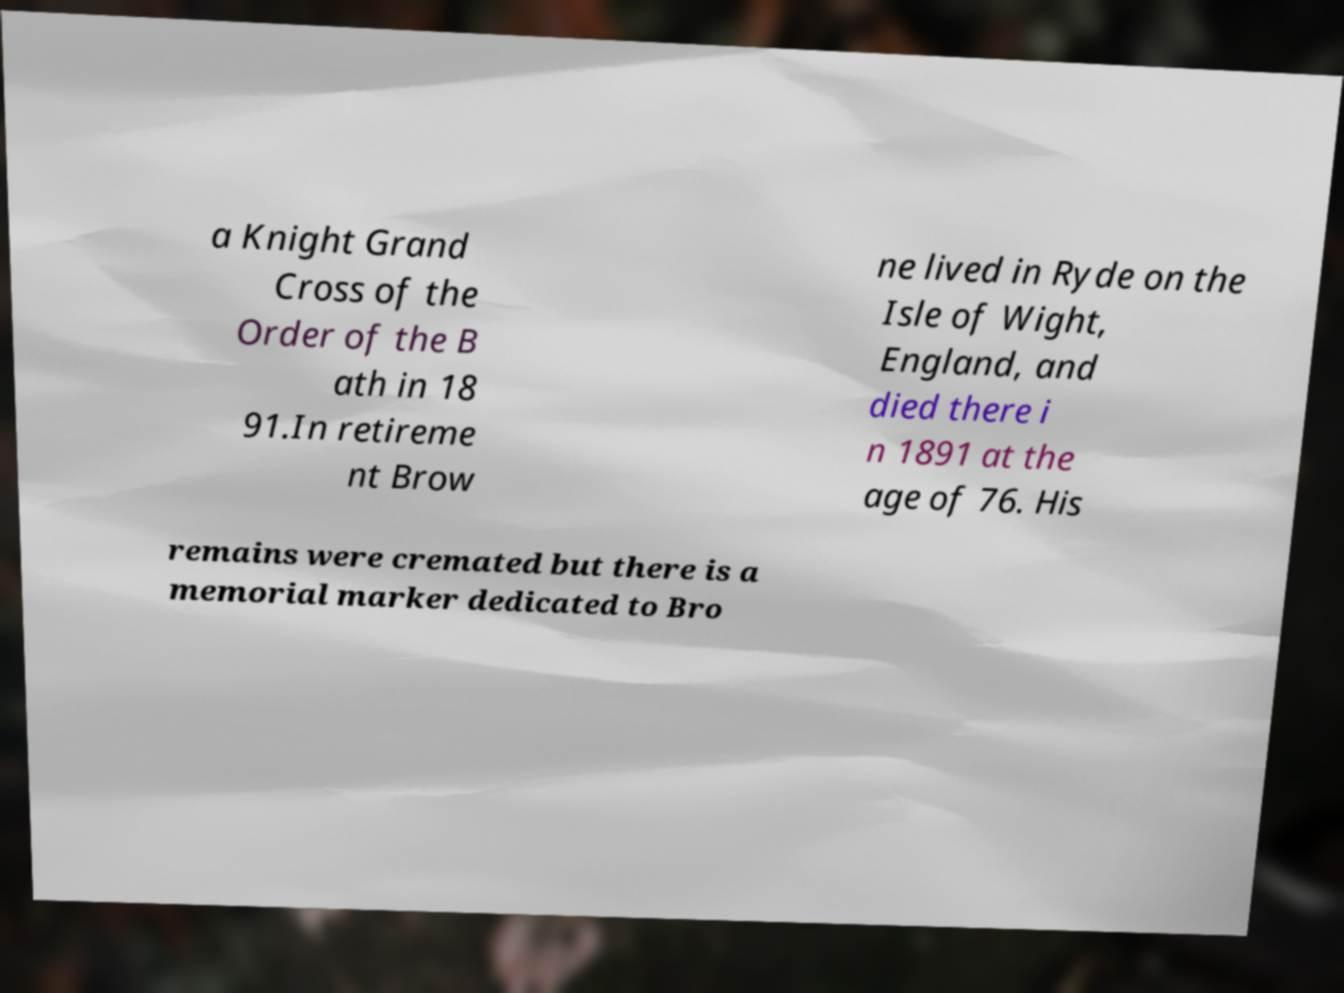There's text embedded in this image that I need extracted. Can you transcribe it verbatim? a Knight Grand Cross of the Order of the B ath in 18 91.In retireme nt Brow ne lived in Ryde on the Isle of Wight, England, and died there i n 1891 at the age of 76. His remains were cremated but there is a memorial marker dedicated to Bro 